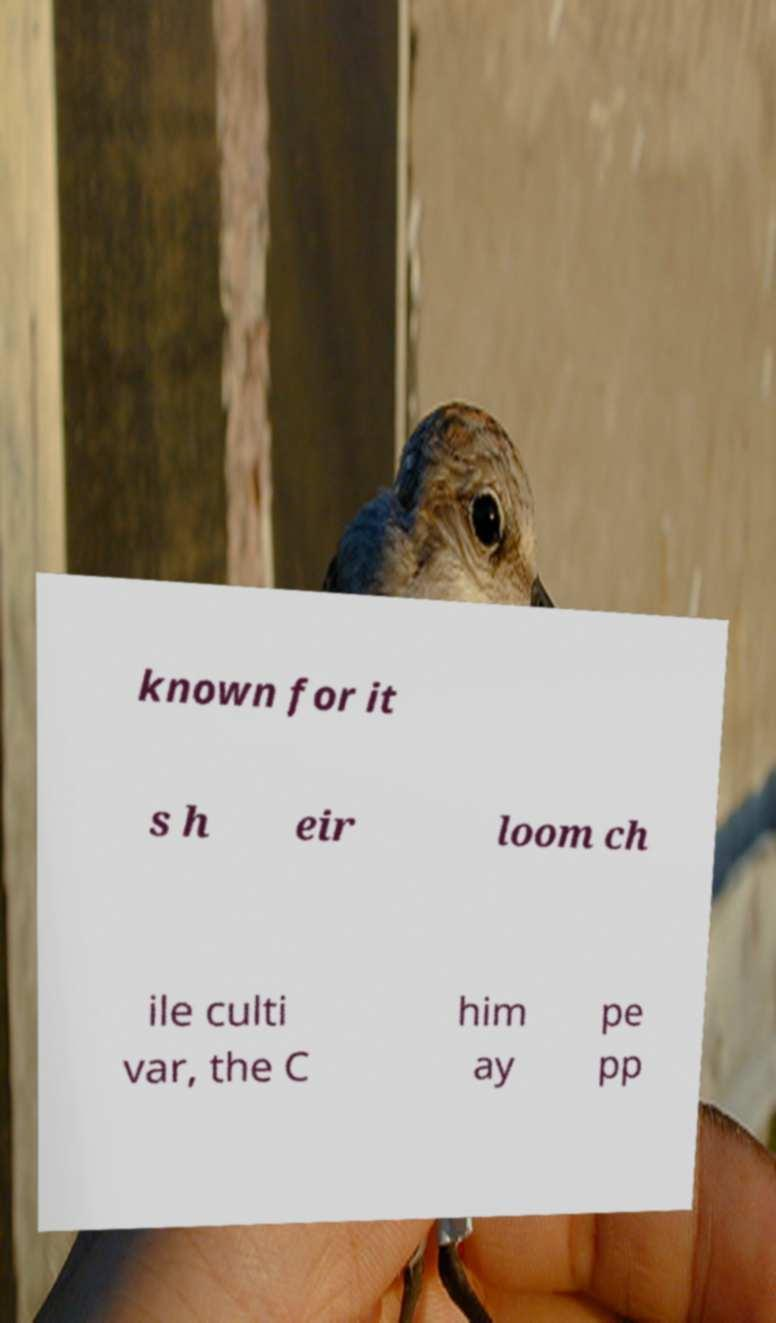There's text embedded in this image that I need extracted. Can you transcribe it verbatim? known for it s h eir loom ch ile culti var, the C him ay pe pp 